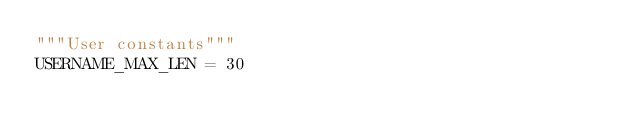<code> <loc_0><loc_0><loc_500><loc_500><_Python_>"""User constants"""
USERNAME_MAX_LEN = 30
</code> 